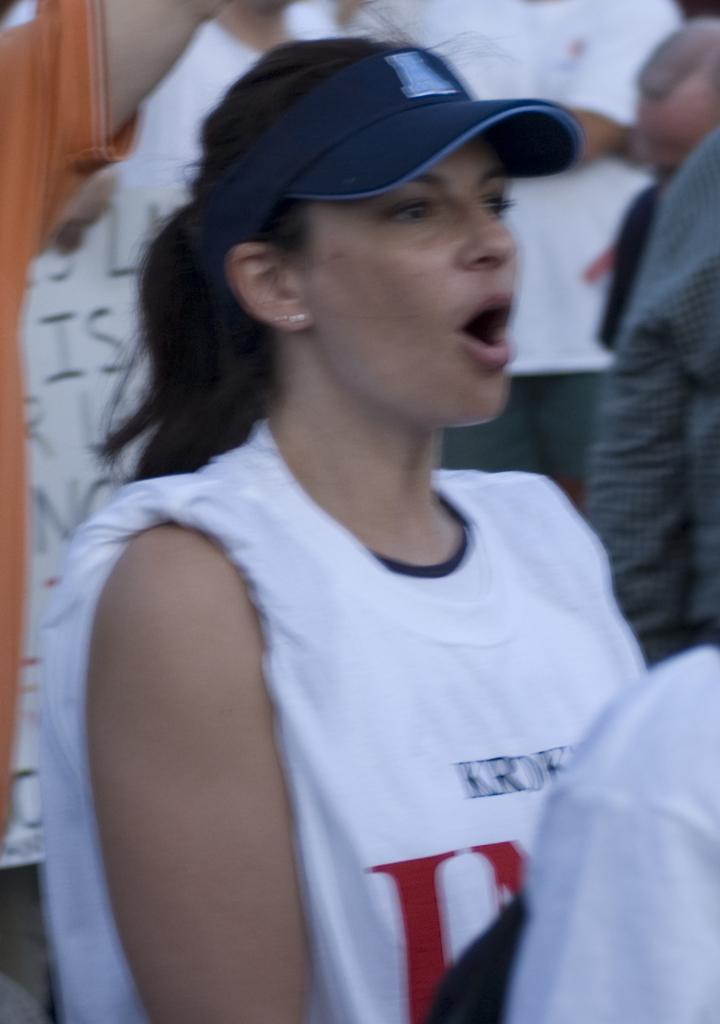In one or two sentences, can you explain what this image depicts? In this picture there is a woman standing at the center wearing a blue colour hat. In the background there are persons and there is a board with some text written on it. 